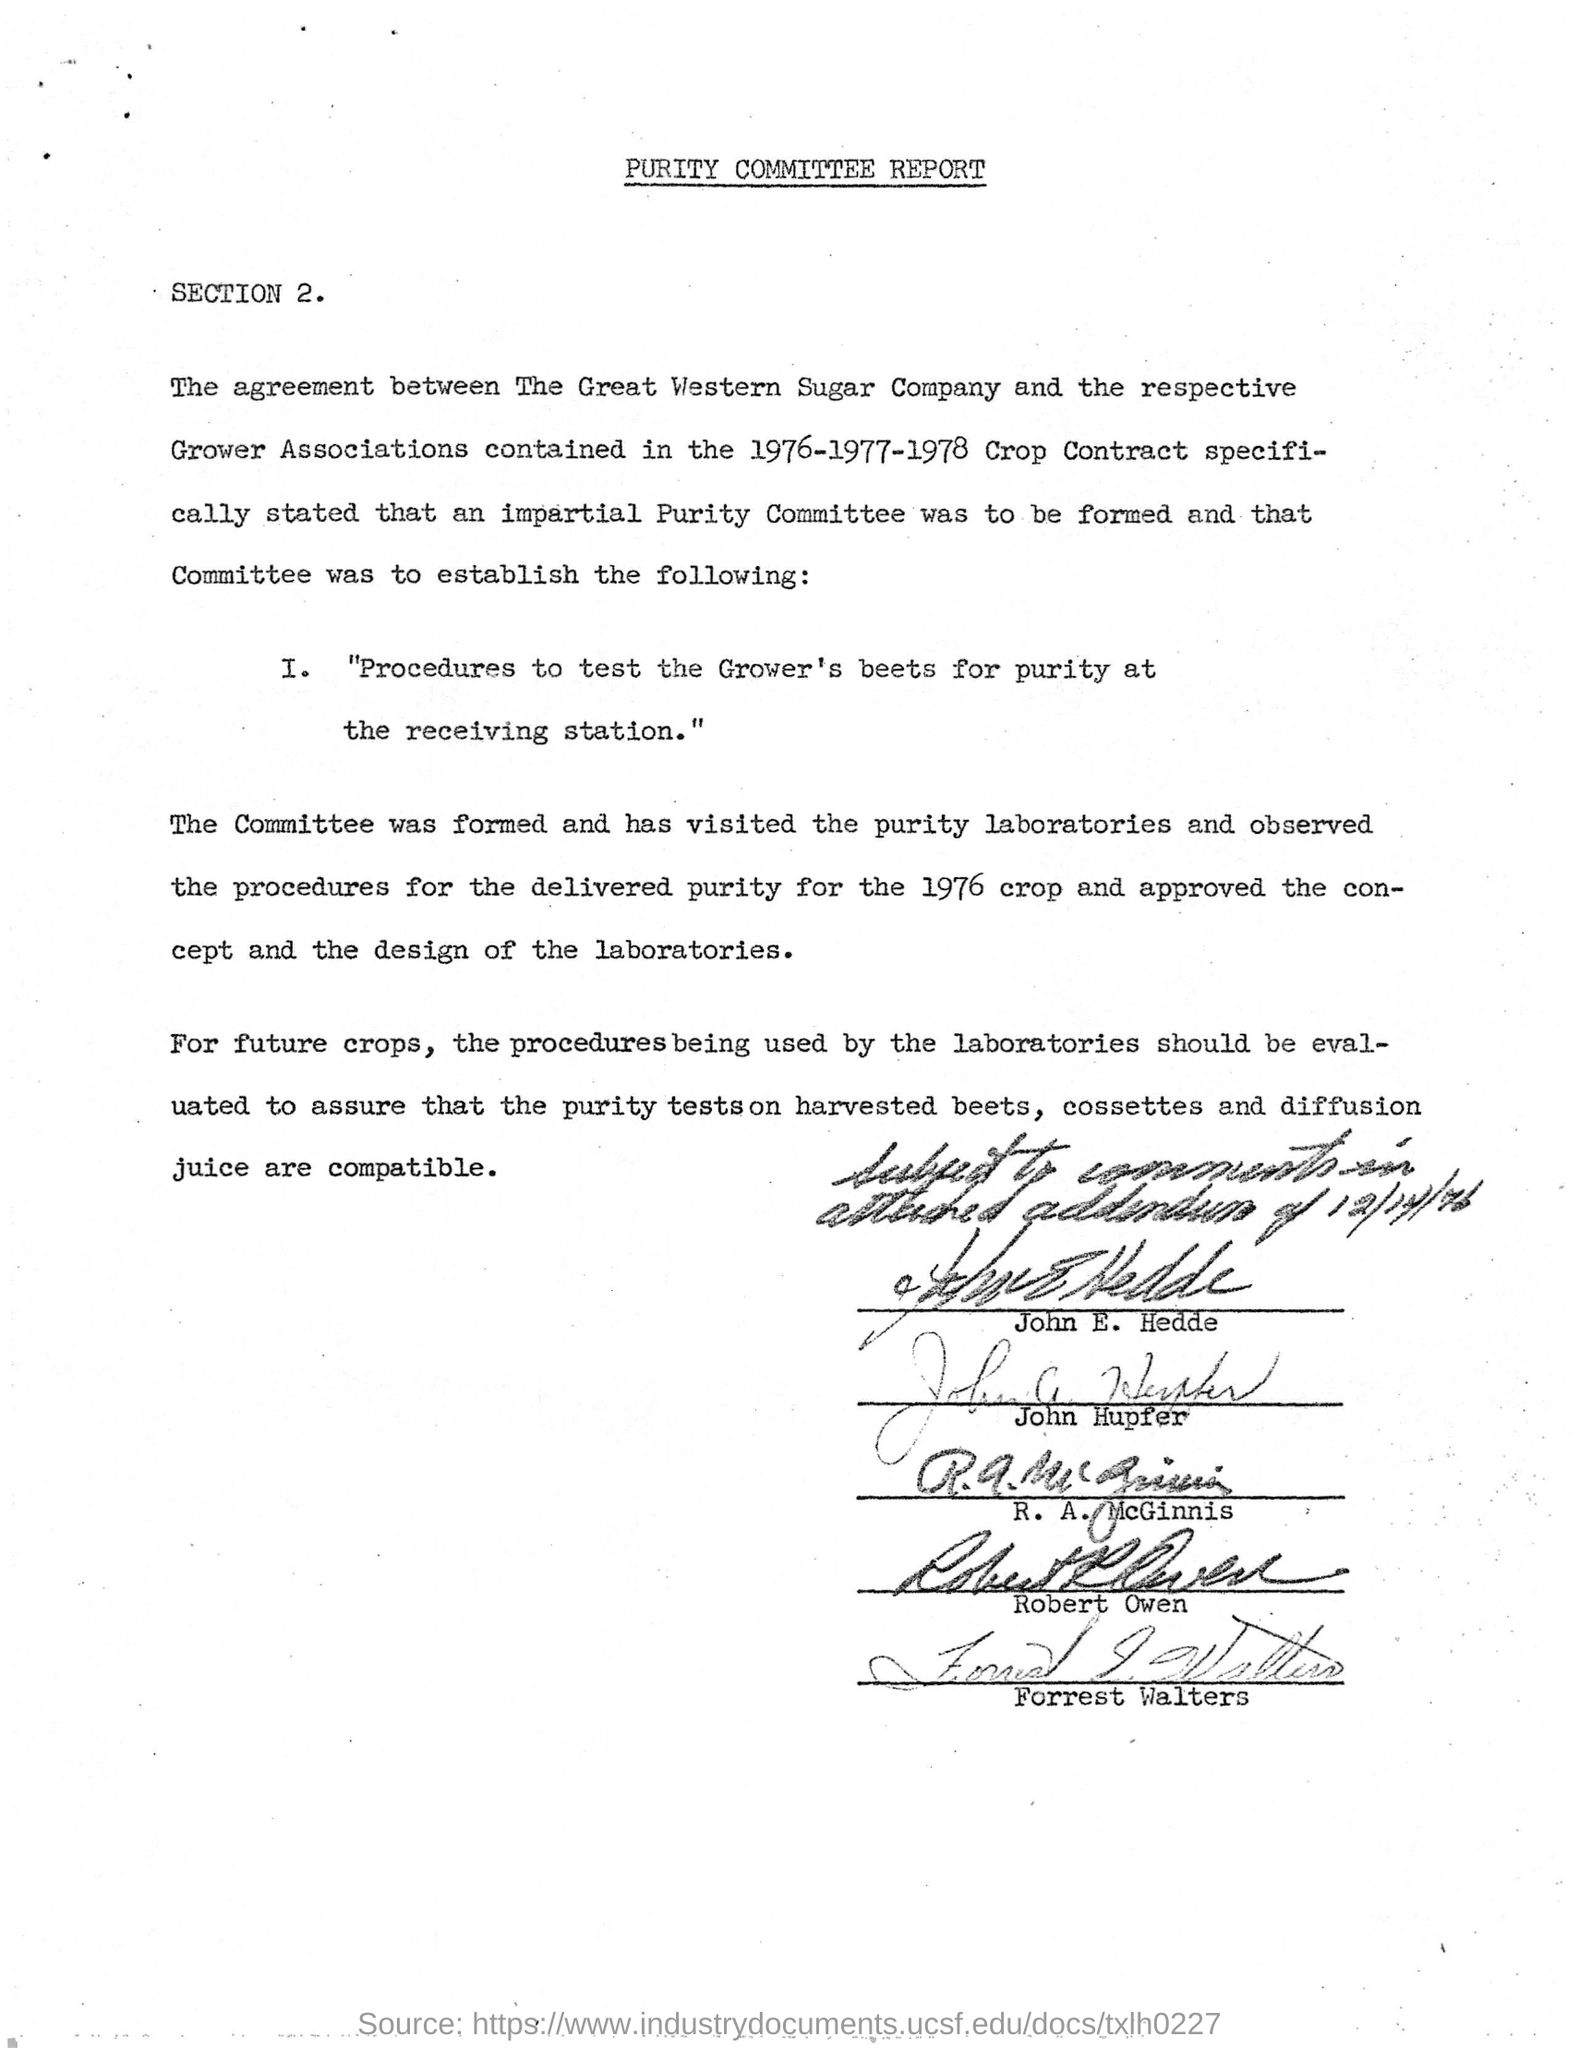Indicate a few pertinent items in this graphic. The 1976-1977-1978 crop contract contains the agreement between The Great Western Sugar company and the respective grower association. 